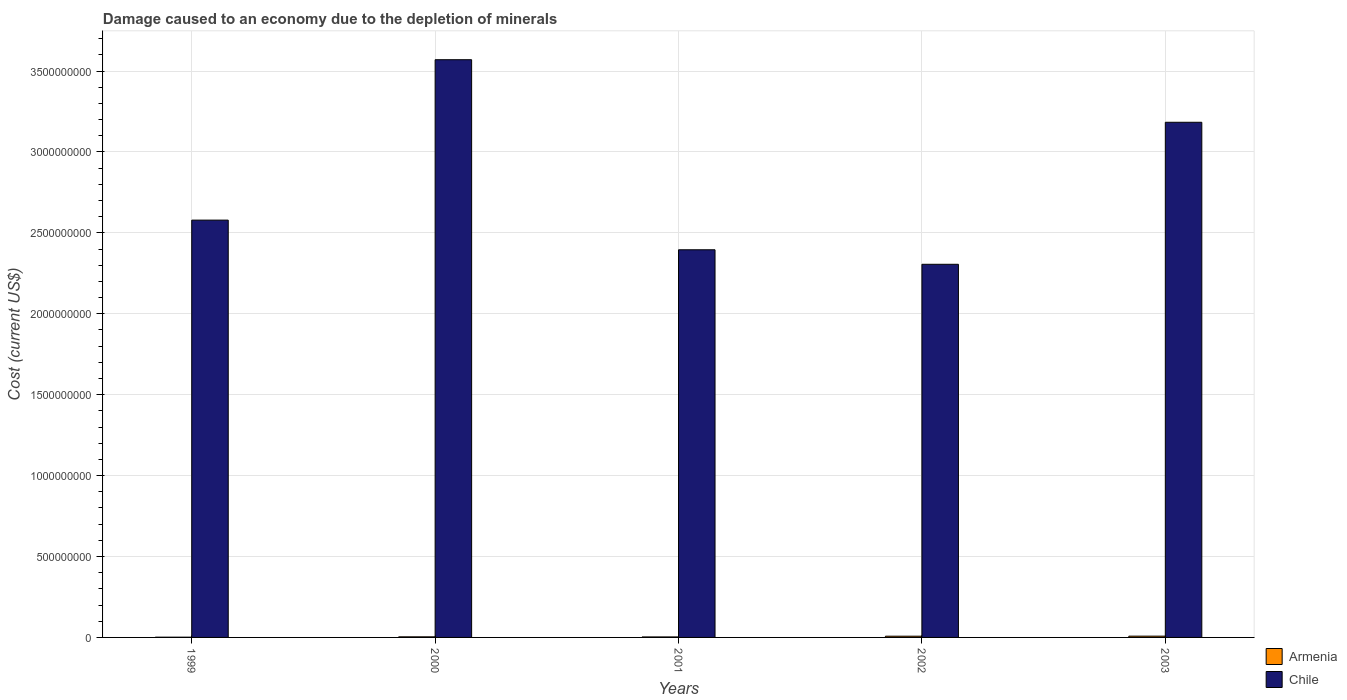How many different coloured bars are there?
Ensure brevity in your answer.  2. How many groups of bars are there?
Your answer should be compact. 5. Are the number of bars on each tick of the X-axis equal?
Make the answer very short. Yes. How many bars are there on the 1st tick from the right?
Your answer should be very brief. 2. In how many cases, is the number of bars for a given year not equal to the number of legend labels?
Offer a very short reply. 0. What is the cost of damage caused due to the depletion of minerals in Chile in 2003?
Give a very brief answer. 3.18e+09. Across all years, what is the maximum cost of damage caused due to the depletion of minerals in Armenia?
Provide a succinct answer. 7.85e+06. Across all years, what is the minimum cost of damage caused due to the depletion of minerals in Chile?
Keep it short and to the point. 2.31e+09. In which year was the cost of damage caused due to the depletion of minerals in Chile maximum?
Make the answer very short. 2000. What is the total cost of damage caused due to the depletion of minerals in Armenia in the graph?
Your response must be concise. 2.36e+07. What is the difference between the cost of damage caused due to the depletion of minerals in Armenia in 1999 and that in 2003?
Make the answer very short. -6.38e+06. What is the difference between the cost of damage caused due to the depletion of minerals in Armenia in 2001 and the cost of damage caused due to the depletion of minerals in Chile in 2002?
Your answer should be very brief. -2.30e+09. What is the average cost of damage caused due to the depletion of minerals in Armenia per year?
Keep it short and to the point. 4.73e+06. In the year 2003, what is the difference between the cost of damage caused due to the depletion of minerals in Chile and cost of damage caused due to the depletion of minerals in Armenia?
Your response must be concise. 3.18e+09. What is the ratio of the cost of damage caused due to the depletion of minerals in Armenia in 2000 to that in 2003?
Provide a short and direct response. 0.47. Is the cost of damage caused due to the depletion of minerals in Chile in 2001 less than that in 2003?
Your response must be concise. Yes. Is the difference between the cost of damage caused due to the depletion of minerals in Chile in 2001 and 2003 greater than the difference between the cost of damage caused due to the depletion of minerals in Armenia in 2001 and 2003?
Keep it short and to the point. No. What is the difference between the highest and the second highest cost of damage caused due to the depletion of minerals in Armenia?
Keep it short and to the point. 2.76e+05. What is the difference between the highest and the lowest cost of damage caused due to the depletion of minerals in Chile?
Keep it short and to the point. 1.26e+09. In how many years, is the cost of damage caused due to the depletion of minerals in Armenia greater than the average cost of damage caused due to the depletion of minerals in Armenia taken over all years?
Ensure brevity in your answer.  2. What does the 2nd bar from the left in 2002 represents?
Your answer should be compact. Chile. What does the 2nd bar from the right in 2002 represents?
Provide a succinct answer. Armenia. How many bars are there?
Your response must be concise. 10. Are all the bars in the graph horizontal?
Your answer should be compact. No. How many years are there in the graph?
Give a very brief answer. 5. What is the difference between two consecutive major ticks on the Y-axis?
Keep it short and to the point. 5.00e+08. Does the graph contain grids?
Ensure brevity in your answer.  Yes. Where does the legend appear in the graph?
Ensure brevity in your answer.  Bottom right. What is the title of the graph?
Offer a very short reply. Damage caused to an economy due to the depletion of minerals. Does "St. Kitts and Nevis" appear as one of the legend labels in the graph?
Offer a terse response. No. What is the label or title of the Y-axis?
Offer a terse response. Cost (current US$). What is the Cost (current US$) in Armenia in 1999?
Provide a short and direct response. 1.47e+06. What is the Cost (current US$) of Chile in 1999?
Your answer should be compact. 2.58e+09. What is the Cost (current US$) in Armenia in 2000?
Keep it short and to the point. 3.65e+06. What is the Cost (current US$) of Chile in 2000?
Make the answer very short. 3.57e+09. What is the Cost (current US$) in Armenia in 2001?
Offer a terse response. 3.09e+06. What is the Cost (current US$) of Chile in 2001?
Give a very brief answer. 2.40e+09. What is the Cost (current US$) in Armenia in 2002?
Provide a succinct answer. 7.58e+06. What is the Cost (current US$) of Chile in 2002?
Your answer should be very brief. 2.31e+09. What is the Cost (current US$) in Armenia in 2003?
Your answer should be compact. 7.85e+06. What is the Cost (current US$) of Chile in 2003?
Your answer should be very brief. 3.18e+09. Across all years, what is the maximum Cost (current US$) in Armenia?
Make the answer very short. 7.85e+06. Across all years, what is the maximum Cost (current US$) in Chile?
Ensure brevity in your answer.  3.57e+09. Across all years, what is the minimum Cost (current US$) of Armenia?
Your response must be concise. 1.47e+06. Across all years, what is the minimum Cost (current US$) in Chile?
Make the answer very short. 2.31e+09. What is the total Cost (current US$) in Armenia in the graph?
Provide a short and direct response. 2.36e+07. What is the total Cost (current US$) in Chile in the graph?
Offer a terse response. 1.40e+1. What is the difference between the Cost (current US$) of Armenia in 1999 and that in 2000?
Your answer should be compact. -2.18e+06. What is the difference between the Cost (current US$) in Chile in 1999 and that in 2000?
Offer a terse response. -9.91e+08. What is the difference between the Cost (current US$) of Armenia in 1999 and that in 2001?
Provide a short and direct response. -1.62e+06. What is the difference between the Cost (current US$) in Chile in 1999 and that in 2001?
Provide a succinct answer. 1.83e+08. What is the difference between the Cost (current US$) of Armenia in 1999 and that in 2002?
Keep it short and to the point. -6.11e+06. What is the difference between the Cost (current US$) in Chile in 1999 and that in 2002?
Your response must be concise. 2.73e+08. What is the difference between the Cost (current US$) of Armenia in 1999 and that in 2003?
Your response must be concise. -6.38e+06. What is the difference between the Cost (current US$) in Chile in 1999 and that in 2003?
Keep it short and to the point. -6.05e+08. What is the difference between the Cost (current US$) in Armenia in 2000 and that in 2001?
Your answer should be very brief. 5.64e+05. What is the difference between the Cost (current US$) of Chile in 2000 and that in 2001?
Keep it short and to the point. 1.17e+09. What is the difference between the Cost (current US$) of Armenia in 2000 and that in 2002?
Make the answer very short. -3.93e+06. What is the difference between the Cost (current US$) in Chile in 2000 and that in 2002?
Make the answer very short. 1.26e+09. What is the difference between the Cost (current US$) in Armenia in 2000 and that in 2003?
Your answer should be compact. -4.20e+06. What is the difference between the Cost (current US$) in Chile in 2000 and that in 2003?
Offer a terse response. 3.87e+08. What is the difference between the Cost (current US$) of Armenia in 2001 and that in 2002?
Ensure brevity in your answer.  -4.49e+06. What is the difference between the Cost (current US$) in Chile in 2001 and that in 2002?
Give a very brief answer. 8.97e+07. What is the difference between the Cost (current US$) of Armenia in 2001 and that in 2003?
Ensure brevity in your answer.  -4.77e+06. What is the difference between the Cost (current US$) in Chile in 2001 and that in 2003?
Make the answer very short. -7.88e+08. What is the difference between the Cost (current US$) in Armenia in 2002 and that in 2003?
Keep it short and to the point. -2.76e+05. What is the difference between the Cost (current US$) in Chile in 2002 and that in 2003?
Your answer should be compact. -8.78e+08. What is the difference between the Cost (current US$) in Armenia in 1999 and the Cost (current US$) in Chile in 2000?
Your response must be concise. -3.57e+09. What is the difference between the Cost (current US$) in Armenia in 1999 and the Cost (current US$) in Chile in 2001?
Offer a very short reply. -2.39e+09. What is the difference between the Cost (current US$) of Armenia in 1999 and the Cost (current US$) of Chile in 2002?
Ensure brevity in your answer.  -2.30e+09. What is the difference between the Cost (current US$) in Armenia in 1999 and the Cost (current US$) in Chile in 2003?
Provide a succinct answer. -3.18e+09. What is the difference between the Cost (current US$) in Armenia in 2000 and the Cost (current US$) in Chile in 2001?
Your answer should be very brief. -2.39e+09. What is the difference between the Cost (current US$) of Armenia in 2000 and the Cost (current US$) of Chile in 2002?
Offer a very short reply. -2.30e+09. What is the difference between the Cost (current US$) in Armenia in 2000 and the Cost (current US$) in Chile in 2003?
Your response must be concise. -3.18e+09. What is the difference between the Cost (current US$) of Armenia in 2001 and the Cost (current US$) of Chile in 2002?
Your answer should be very brief. -2.30e+09. What is the difference between the Cost (current US$) of Armenia in 2001 and the Cost (current US$) of Chile in 2003?
Give a very brief answer. -3.18e+09. What is the difference between the Cost (current US$) of Armenia in 2002 and the Cost (current US$) of Chile in 2003?
Give a very brief answer. -3.18e+09. What is the average Cost (current US$) of Armenia per year?
Ensure brevity in your answer.  4.73e+06. What is the average Cost (current US$) of Chile per year?
Keep it short and to the point. 2.81e+09. In the year 1999, what is the difference between the Cost (current US$) in Armenia and Cost (current US$) in Chile?
Keep it short and to the point. -2.58e+09. In the year 2000, what is the difference between the Cost (current US$) in Armenia and Cost (current US$) in Chile?
Your response must be concise. -3.57e+09. In the year 2001, what is the difference between the Cost (current US$) in Armenia and Cost (current US$) in Chile?
Offer a terse response. -2.39e+09. In the year 2002, what is the difference between the Cost (current US$) in Armenia and Cost (current US$) in Chile?
Offer a terse response. -2.30e+09. In the year 2003, what is the difference between the Cost (current US$) in Armenia and Cost (current US$) in Chile?
Offer a terse response. -3.18e+09. What is the ratio of the Cost (current US$) of Armenia in 1999 to that in 2000?
Ensure brevity in your answer.  0.4. What is the ratio of the Cost (current US$) in Chile in 1999 to that in 2000?
Provide a short and direct response. 0.72. What is the ratio of the Cost (current US$) of Armenia in 1999 to that in 2001?
Offer a terse response. 0.48. What is the ratio of the Cost (current US$) in Chile in 1999 to that in 2001?
Your response must be concise. 1.08. What is the ratio of the Cost (current US$) in Armenia in 1999 to that in 2002?
Ensure brevity in your answer.  0.19. What is the ratio of the Cost (current US$) of Chile in 1999 to that in 2002?
Your answer should be very brief. 1.12. What is the ratio of the Cost (current US$) of Armenia in 1999 to that in 2003?
Offer a very short reply. 0.19. What is the ratio of the Cost (current US$) of Chile in 1999 to that in 2003?
Keep it short and to the point. 0.81. What is the ratio of the Cost (current US$) in Armenia in 2000 to that in 2001?
Offer a very short reply. 1.18. What is the ratio of the Cost (current US$) in Chile in 2000 to that in 2001?
Your response must be concise. 1.49. What is the ratio of the Cost (current US$) of Armenia in 2000 to that in 2002?
Offer a very short reply. 0.48. What is the ratio of the Cost (current US$) of Chile in 2000 to that in 2002?
Ensure brevity in your answer.  1.55. What is the ratio of the Cost (current US$) of Armenia in 2000 to that in 2003?
Offer a very short reply. 0.47. What is the ratio of the Cost (current US$) of Chile in 2000 to that in 2003?
Your response must be concise. 1.12. What is the ratio of the Cost (current US$) in Armenia in 2001 to that in 2002?
Your response must be concise. 0.41. What is the ratio of the Cost (current US$) of Chile in 2001 to that in 2002?
Make the answer very short. 1.04. What is the ratio of the Cost (current US$) of Armenia in 2001 to that in 2003?
Your answer should be very brief. 0.39. What is the ratio of the Cost (current US$) in Chile in 2001 to that in 2003?
Make the answer very short. 0.75. What is the ratio of the Cost (current US$) in Armenia in 2002 to that in 2003?
Your answer should be compact. 0.96. What is the ratio of the Cost (current US$) in Chile in 2002 to that in 2003?
Ensure brevity in your answer.  0.72. What is the difference between the highest and the second highest Cost (current US$) in Armenia?
Keep it short and to the point. 2.76e+05. What is the difference between the highest and the second highest Cost (current US$) in Chile?
Offer a very short reply. 3.87e+08. What is the difference between the highest and the lowest Cost (current US$) of Armenia?
Give a very brief answer. 6.38e+06. What is the difference between the highest and the lowest Cost (current US$) of Chile?
Offer a terse response. 1.26e+09. 